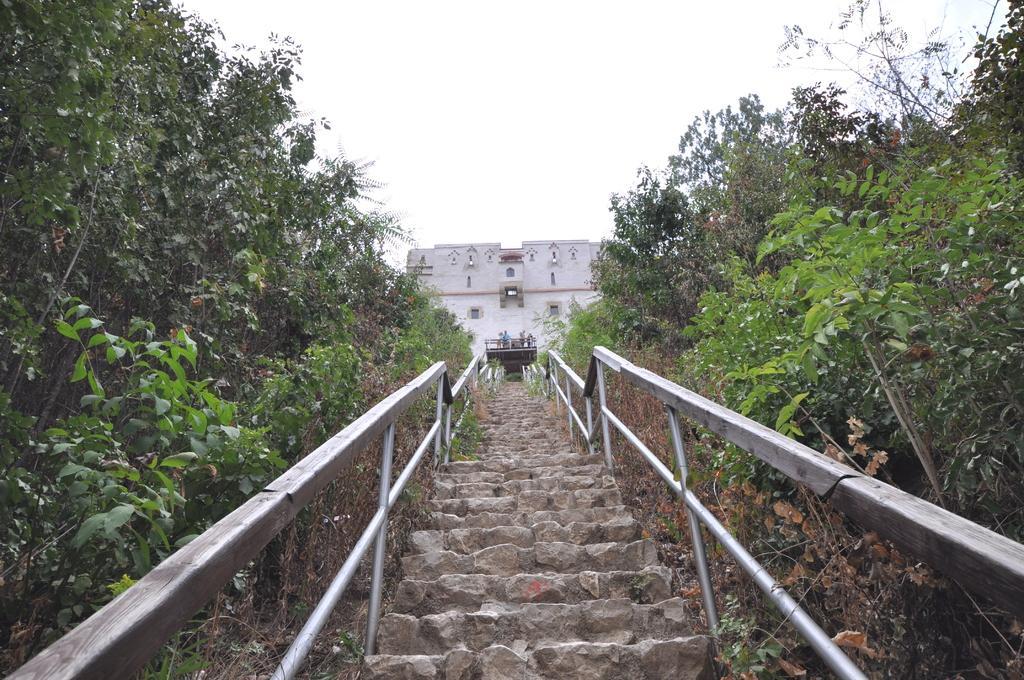In one or two sentences, can you explain what this image depicts? In the center of the image we can see stairs. Image also consists of a building and also many trees. At the top we can see the sky. 